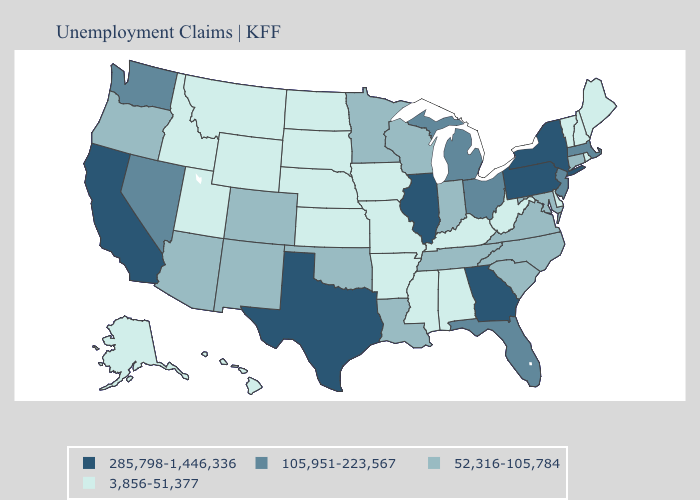What is the highest value in the USA?
Concise answer only. 285,798-1,446,336. What is the highest value in states that border Utah?
Concise answer only. 105,951-223,567. Does Vermont have the lowest value in the Northeast?
Short answer required. Yes. Name the states that have a value in the range 52,316-105,784?
Concise answer only. Arizona, Colorado, Connecticut, Indiana, Louisiana, Maryland, Minnesota, New Mexico, North Carolina, Oklahoma, Oregon, South Carolina, Tennessee, Virginia, Wisconsin. Name the states that have a value in the range 285,798-1,446,336?
Concise answer only. California, Georgia, Illinois, New York, Pennsylvania, Texas. Name the states that have a value in the range 3,856-51,377?
Short answer required. Alabama, Alaska, Arkansas, Delaware, Hawaii, Idaho, Iowa, Kansas, Kentucky, Maine, Mississippi, Missouri, Montana, Nebraska, New Hampshire, North Dakota, Rhode Island, South Dakota, Utah, Vermont, West Virginia, Wyoming. What is the highest value in states that border Wyoming?
Concise answer only. 52,316-105,784. Name the states that have a value in the range 105,951-223,567?
Keep it brief. Florida, Massachusetts, Michigan, Nevada, New Jersey, Ohio, Washington. Does Illinois have the highest value in the MidWest?
Give a very brief answer. Yes. Which states have the lowest value in the Northeast?
Keep it brief. Maine, New Hampshire, Rhode Island, Vermont. What is the value of Idaho?
Quick response, please. 3,856-51,377. What is the value of Louisiana?
Answer briefly. 52,316-105,784. What is the value of Georgia?
Quick response, please. 285,798-1,446,336. Does Virginia have the highest value in the USA?
Concise answer only. No. What is the value of Pennsylvania?
Be succinct. 285,798-1,446,336. 